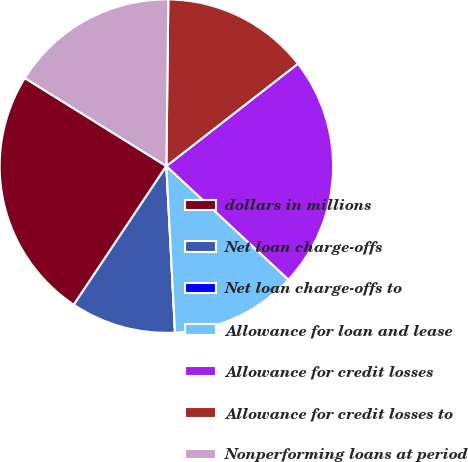Convert chart. <chart><loc_0><loc_0><loc_500><loc_500><pie_chart><fcel>dollars in millions<fcel>Net loan charge-offs<fcel>Net loan charge-offs to<fcel>Allowance for loan and lease<fcel>Allowance for credit losses<fcel>Allowance for credit losses to<fcel>Nonperforming loans at period<nl><fcel>24.49%<fcel>10.2%<fcel>0.0%<fcel>12.25%<fcel>22.45%<fcel>14.29%<fcel>16.33%<nl></chart> 